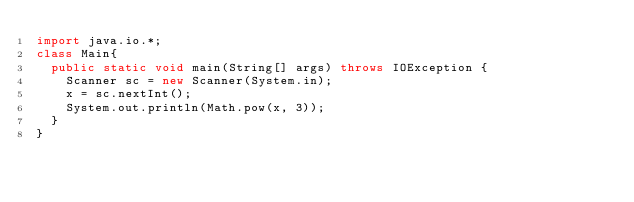Convert code to text. <code><loc_0><loc_0><loc_500><loc_500><_Java_>import java.io.*;
class Main{
  public static void main(String[] args) throws IOException {
    Scanner sc = new Scanner(System.in);
    x = sc.nextInt();
    System.out.println(Math.pow(x, 3));
  }
}</code> 